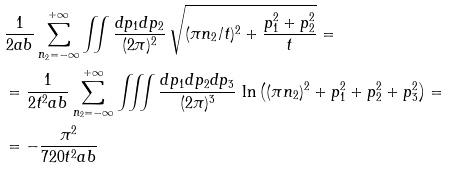Convert formula to latex. <formula><loc_0><loc_0><loc_500><loc_500>& \frac { 1 } { 2 a b } \sum _ { n _ { 2 } = - \infty } ^ { + \infty } \iint \frac { d p _ { 1 } d p _ { 2 } } { ( 2 \pi ) ^ { 2 } } \, \sqrt { ( \pi n _ { 2 } / t ) ^ { 2 } + \frac { p _ { 1 } ^ { 2 } + p _ { 2 } ^ { 2 } } { t } } = \\ & = \frac { 1 } { 2 t ^ { 2 } a b } \sum _ { n _ { 2 } = - \infty } ^ { + \infty } \iiint \frac { d p _ { 1 } d p _ { 2 } d p _ { 3 } } { ( 2 \pi ) ^ { 3 } } \, \ln \left ( ( \pi n _ { 2 } ) ^ { 2 } + p _ { 1 } ^ { 2 } + p _ { 2 } ^ { 2 } + p _ { 3 } ^ { 2 } \right ) = \\ & = - \frac { \pi ^ { 2 } } { 7 2 0 t ^ { 2 } a b }</formula> 